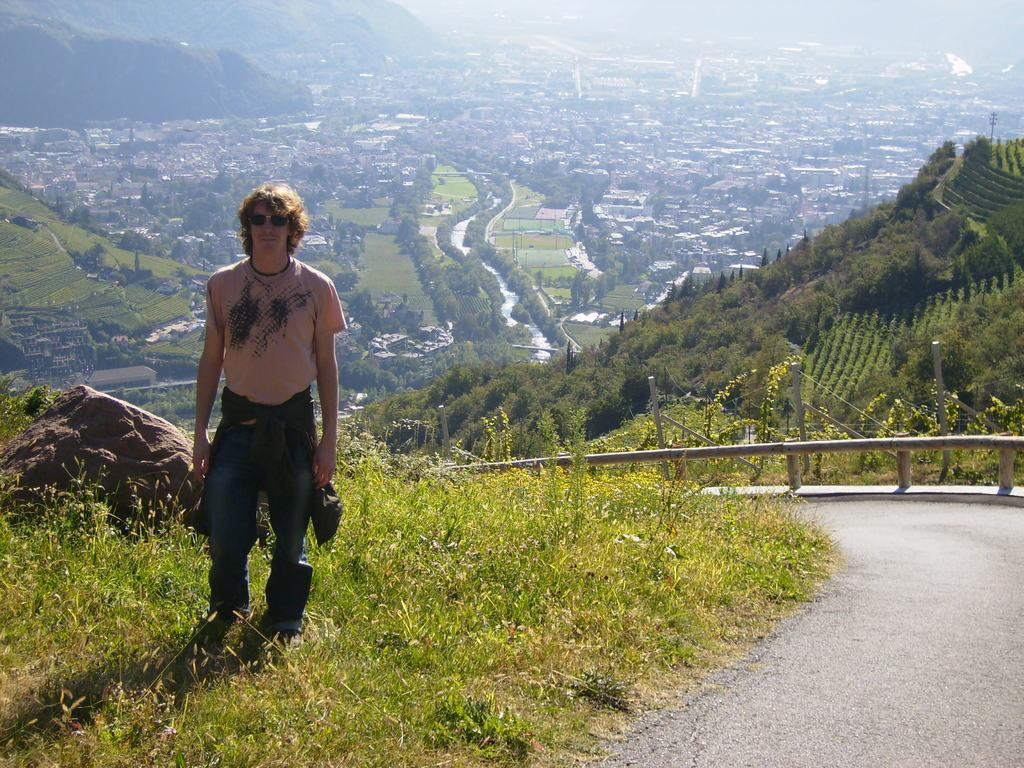In one or two sentences, can you explain what this image depicts? This is an outside view. On the left side there is a man standing on the ground and giving pose for the picture. At the back of him there is a rock and there are many plants. On the right side there is a road. Beside the road there is a railing. In the background there are many buildings, trees and hills. 